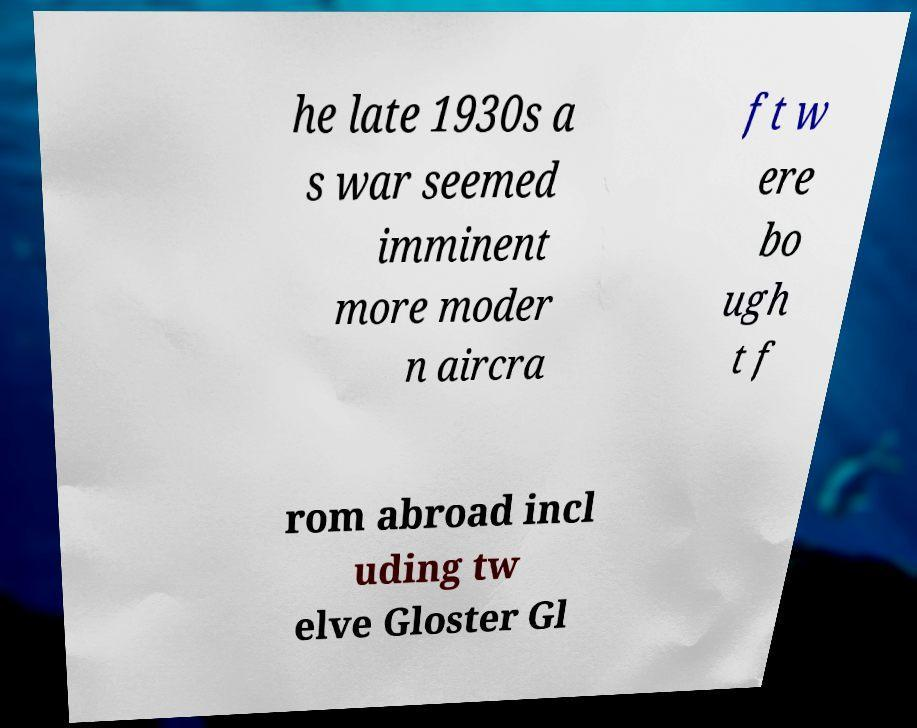Could you extract and type out the text from this image? he late 1930s a s war seemed imminent more moder n aircra ft w ere bo ugh t f rom abroad incl uding tw elve Gloster Gl 